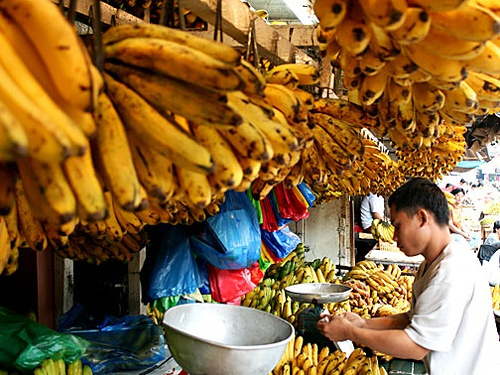Describe the objects in this image and their specific colors. I can see banana in maroon, brown, orange, and black tones, banana in maroon, brown, orange, and black tones, people in maroon, white, black, and brown tones, banana in maroon, orange, brown, and black tones, and bowl in maroon, white, darkgray, gray, and darkgreen tones in this image. 